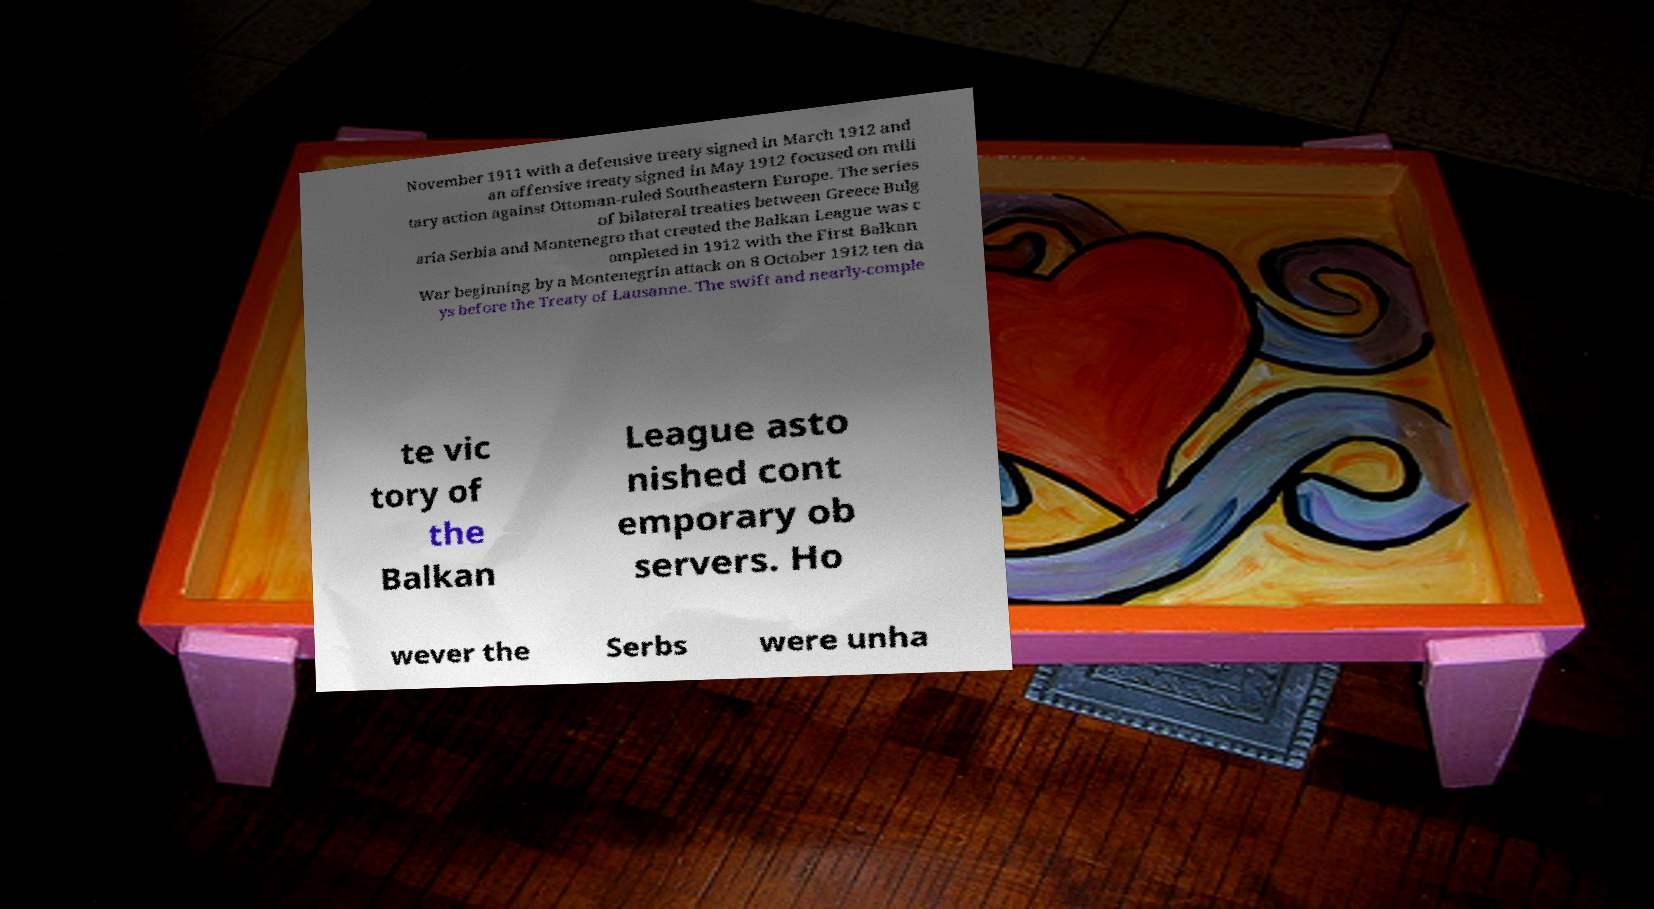Could you extract and type out the text from this image? November 1911 with a defensive treaty signed in March 1912 and an offensive treaty signed in May 1912 focused on mili tary action against Ottoman-ruled Southeastern Europe. The series of bilateral treaties between Greece Bulg aria Serbia and Montenegro that created the Balkan League was c ompleted in 1912 with the First Balkan War beginning by a Montenegrin attack on 8 October 1912 ten da ys before the Treaty of Lausanne. The swift and nearly-comple te vic tory of the Balkan League asto nished cont emporary ob servers. Ho wever the Serbs were unha 